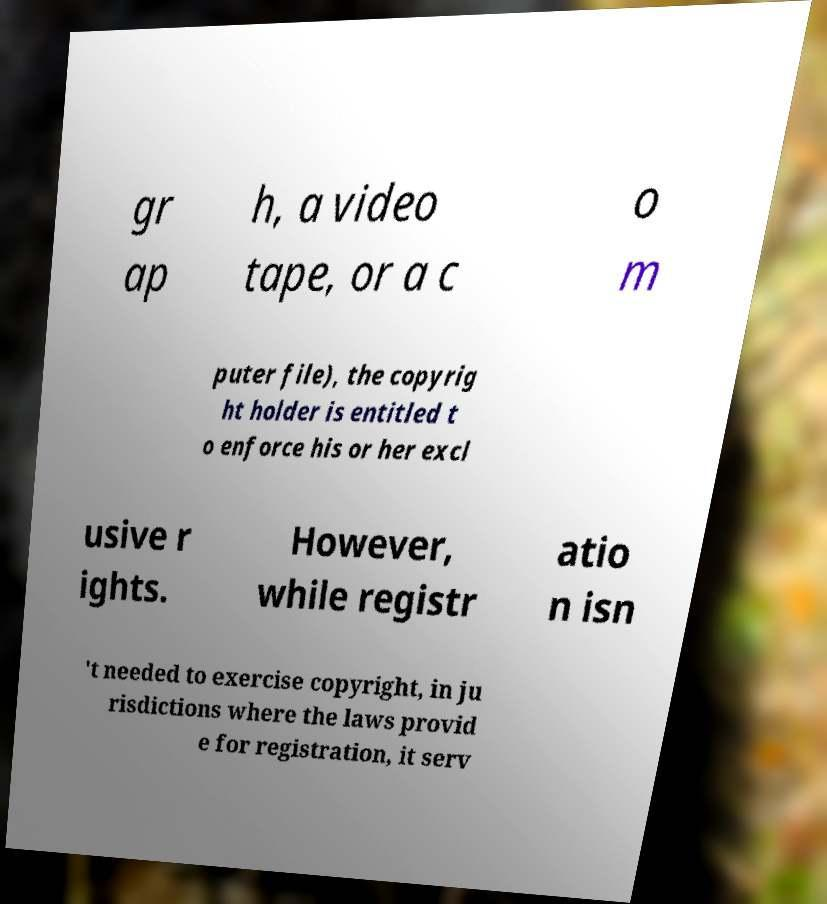For documentation purposes, I need the text within this image transcribed. Could you provide that? gr ap h, a video tape, or a c o m puter file), the copyrig ht holder is entitled t o enforce his or her excl usive r ights. However, while registr atio n isn 't needed to exercise copyright, in ju risdictions where the laws provid e for registration, it serv 